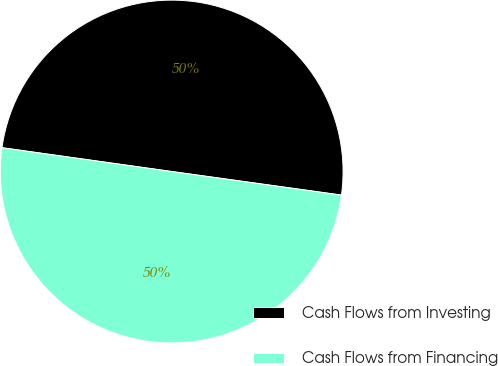Convert chart to OTSL. <chart><loc_0><loc_0><loc_500><loc_500><pie_chart><fcel>Cash Flows from Investing<fcel>Cash Flows from Financing<nl><fcel>49.98%<fcel>50.02%<nl></chart> 